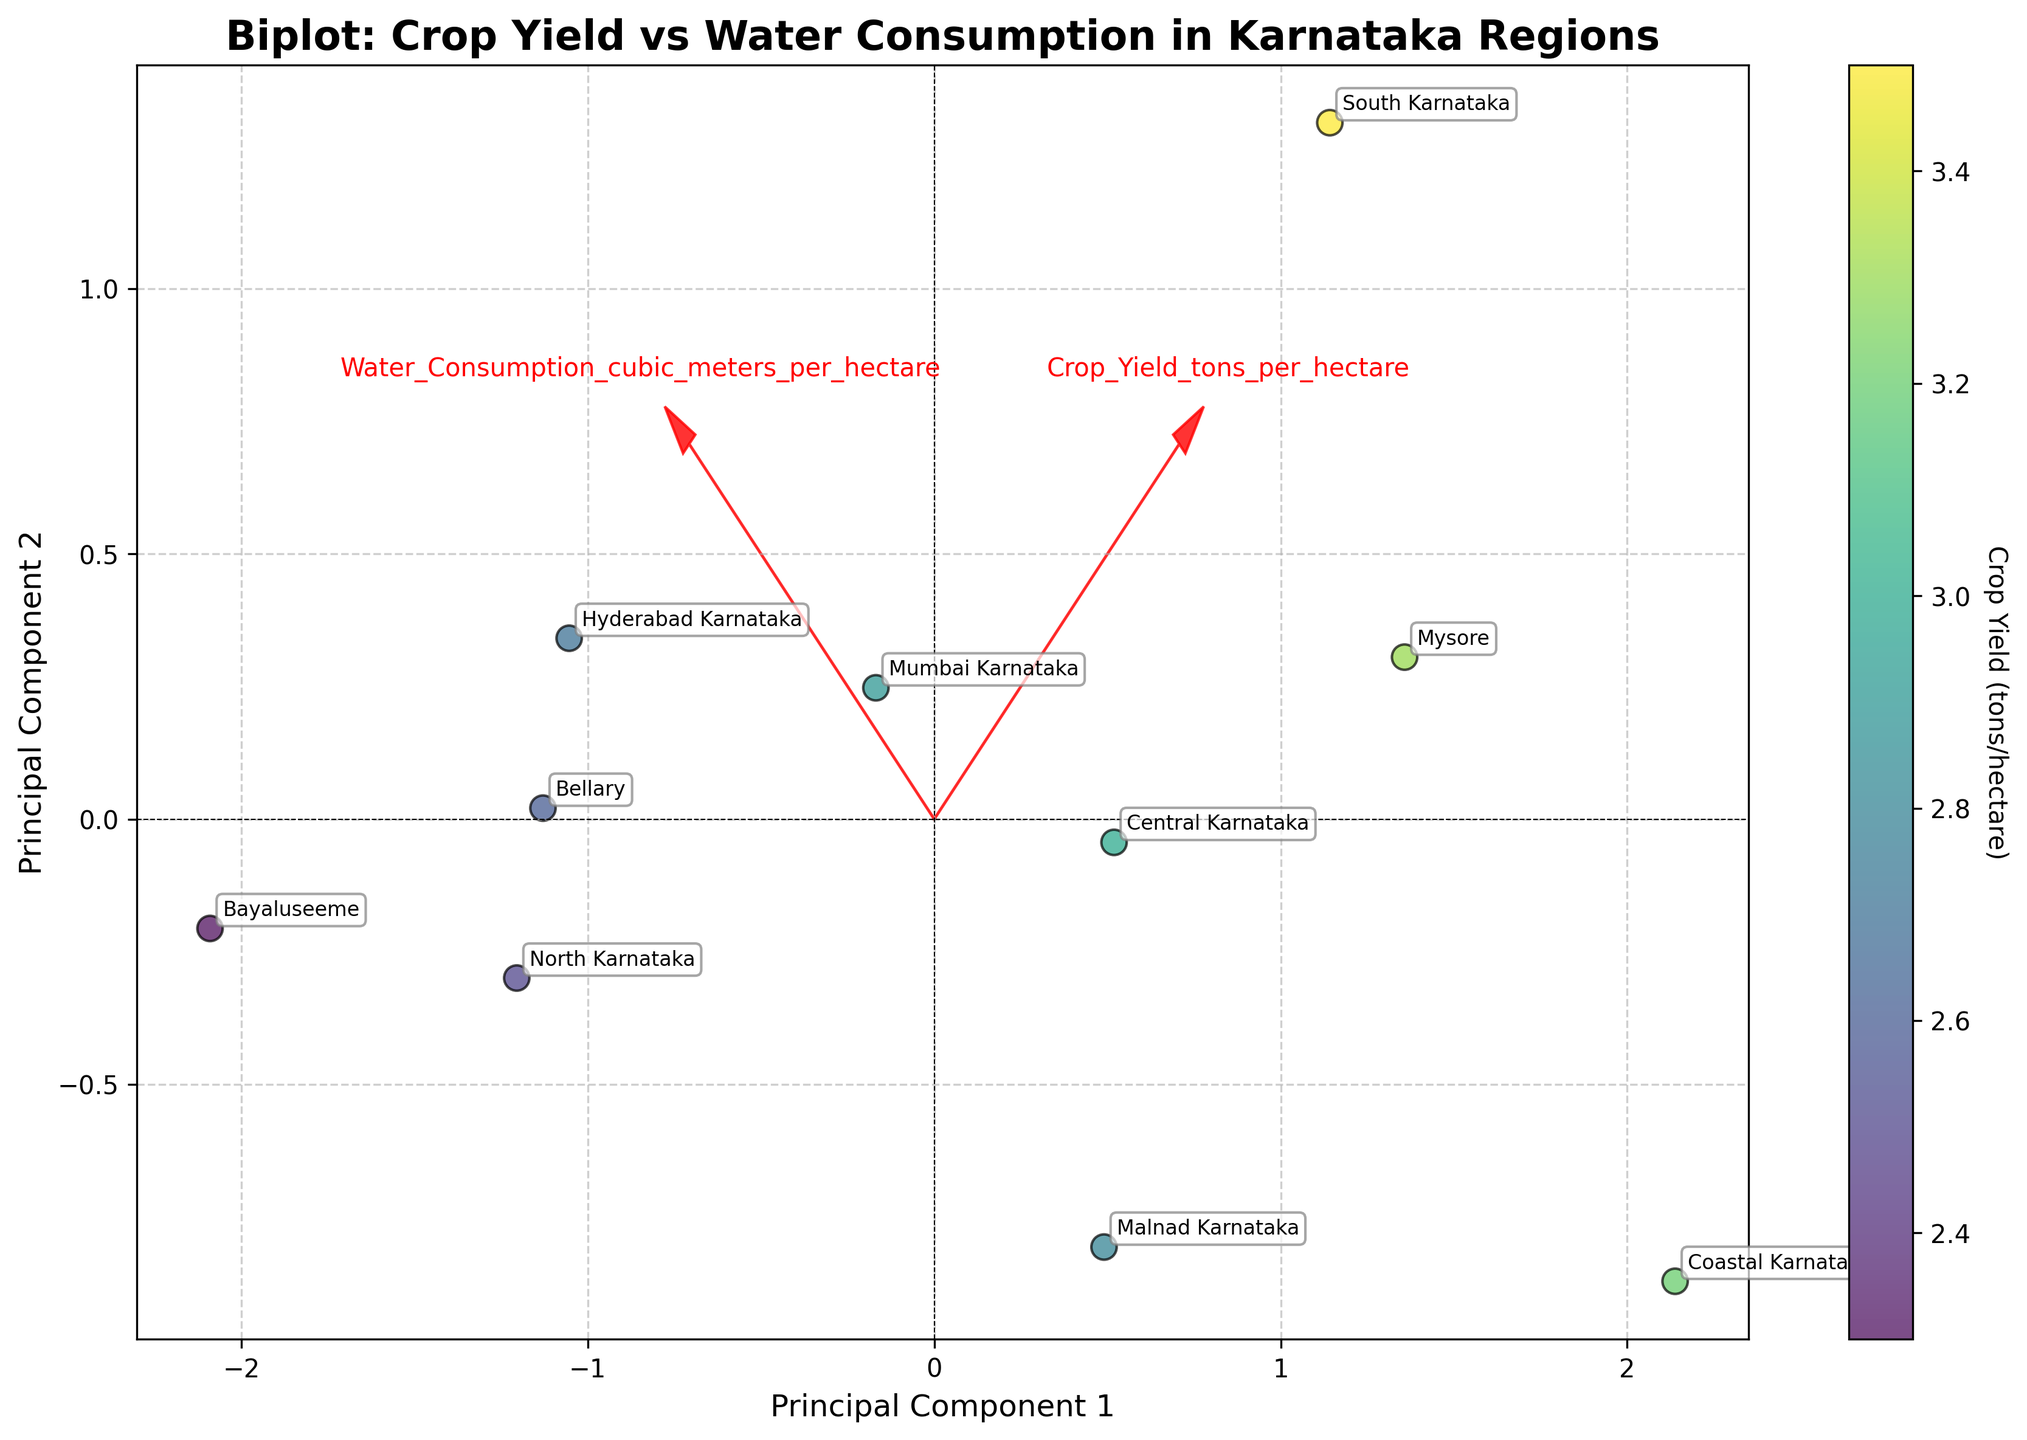What are the axes labeled in the plot? The plot shows the labels for the x-axis as "Principal Component 1" and the y-axis as "Principal Component 2". These axes represent the principal components derived from the PCA transformation of the dataset.
Answer: Principal Component 1 and Principal Component 2 Which region has the highest crop yield? By looking at the biplot, the region with the highest crop yield will be the one with the highest value on the colorbar. The marker for South Karnataka appears to be the highest based on the color gradient.
Answer: South Karnataka Which region uses the most water for agriculture? By identifying the position of the indicators in the biplot, Bellary appears to be positioned farthest along the vector representing water consumption, indicating it uses the most water.
Answer: Bellary How do the crop yield and water consumption compare between Coastal Karnataka and Bayaluseeme? Coastal Karnataka has a higher crop yield and lower water consumption compared to Bayaluseeme. This can be deduced from the coordinates in the biplot, where Coastal Karnataka is closer to the positive axis of the crop yield component and Bayaluseeme is farther along the water consumption vector.
Answer: Coastal Karnataka has higher crop yield and lower water consumption What is the trend observed between crop yield and water consumption across Karnataka's regions? The biplot shows that regions with higher water consumption tend to have lower crop yields. This is indicated by the opposing directions of the vectors representing crop yield and water consumption.
Answer: Higher water consumption tends to coincide with lower crop yields Which regions fall within the central cluster based on principal components? The central cluster broadly includes Malnad Karnataka, Central Karnataka, and Mysore, visible from their proximity around the origin in the biplot.
Answer: Malnad Karnataka, Central Karnataka, Mysore Which region is most divergent in the biplot for water consumption? Bellary is most divergent for water consumption as it is most distant from the origin along the water consumption vector direction.
Answer: Bellary What feature vectors are included in the biplot and how do they influence the plot interpretation? The two feature vectors shown are 'Crop_Yield_tons_per_hectare' and 'Water_Consumption_cubic_meters_per_hectare'. These vectors help illustrate the contribution of each feature to the principal components, with crop yield negatively correlated with water consumption.
Answer: Crop_Yield_tons_per_hectare and Water_Consumption_cubic_meters_per_hectare Which regions have crop yields close to the average crop yield of approximately 3.0 tons per hectare? By observing the color gradient and alignment to the crop yield vector, Mysore, Coastal Karnataka, and Central Karnataka exhibit crop yields near the average value of 3.0 tons per hectare.
Answer: Mysore, Coastal Karnataka, Central Karnataka 